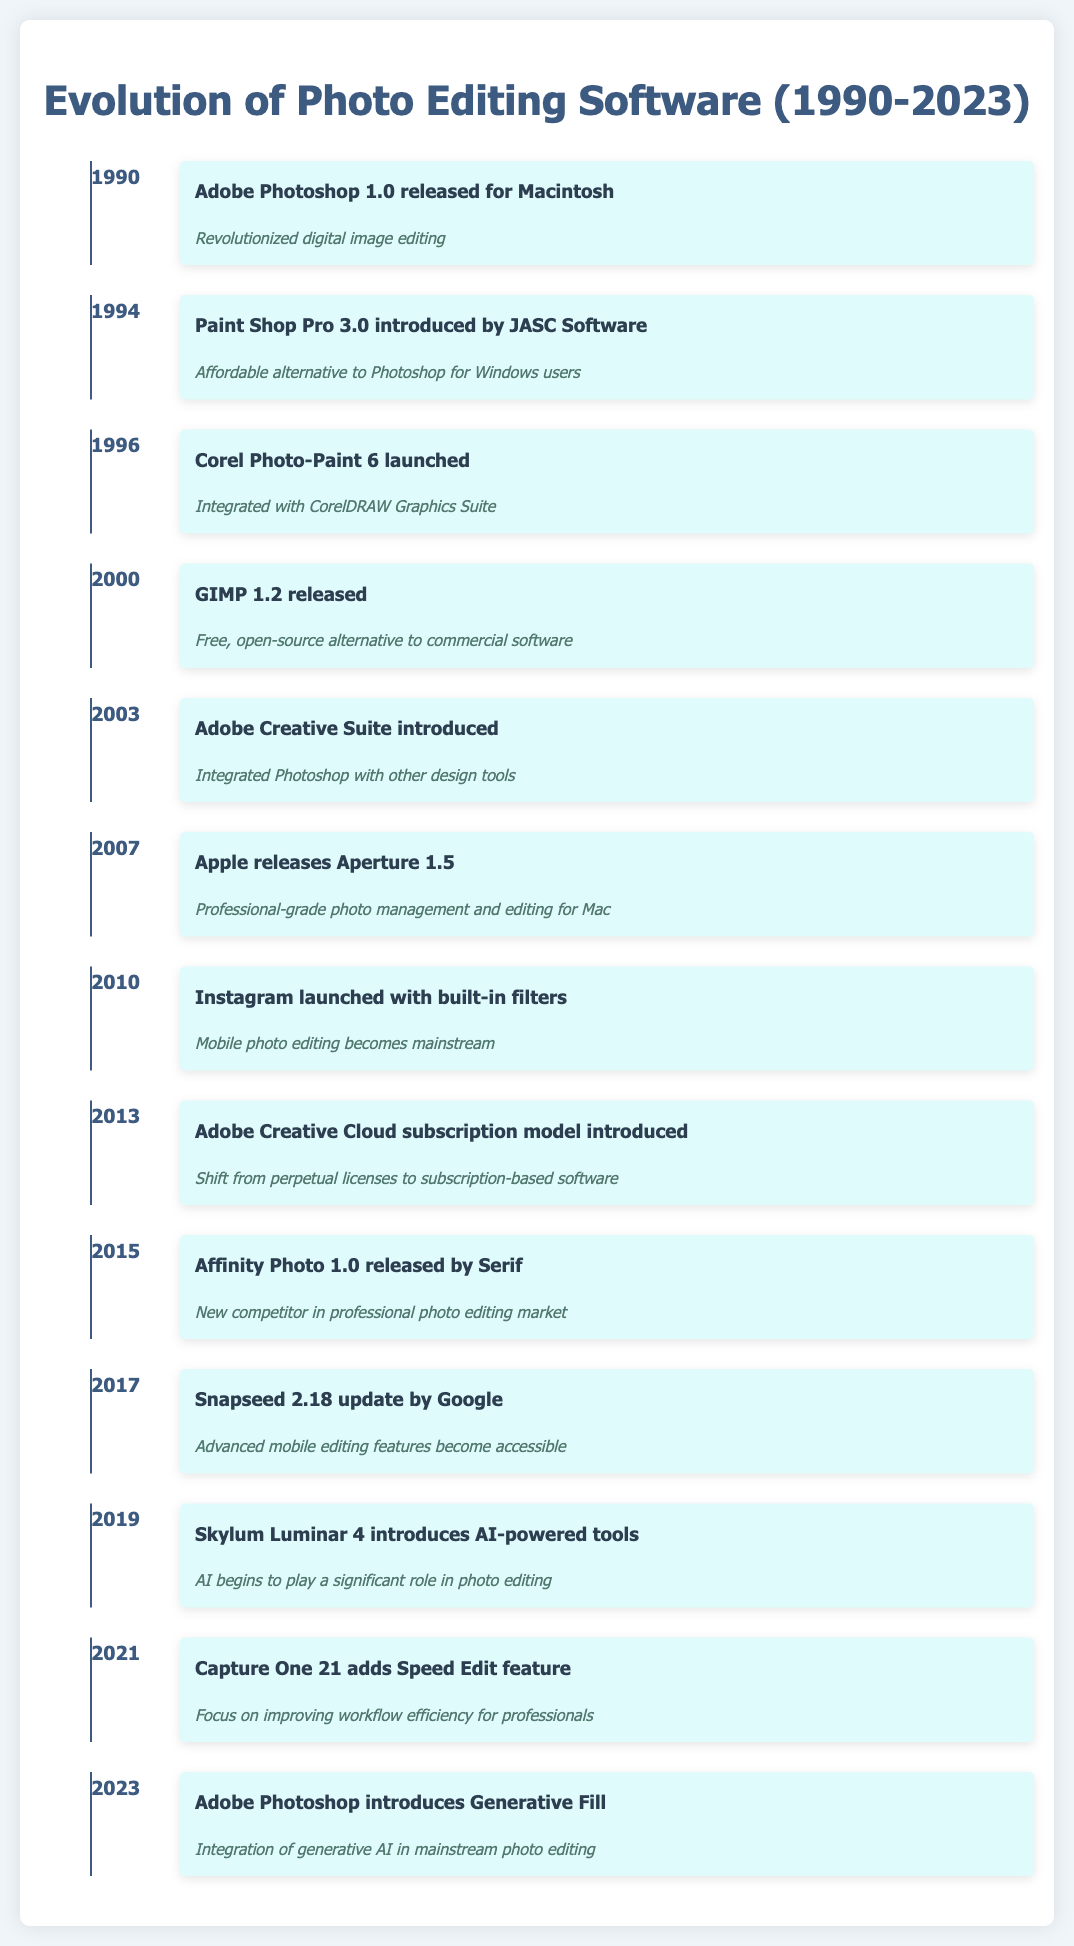What software was released in 1994? The table indicates that in 1994, "Paint Shop Pro 3.0 introduced by JASC Software" was the key event.
Answer: Paint Shop Pro 3.0 What significant change occurred in 2013 with Adobe Creative Cloud? The table states that in 2013, "Adobe Creative Cloud subscription model introduced," marking a shift from perpetual licenses to subscription-based models.
Answer: Shift to subscription model Which software was the first open-source alternative listed, and when was it released? The table indicates that "GIMP 1.2 released" in 2000 was the first open-source alternative mentioned.
Answer: GIMP 1.2 in 2000 Which three events mention advances related to mobile photo editing? The table highlights three relevant events: "Instagram launched with built-in filters" in 2010, "Snapseed 2.18 update by Google" in 2017, and "AI begins to play a significant role in photo editing" with "Skylum Luminar 4" in 2019.
Answer: Instagram 2010, Snapseed 2017, Luminar 2019 In what year was generative AI integrated into Adobe Photoshop? The table indicates that "Adobe Photoshop introduces Generative Fill" in 2023, marking the integration of generative AI.
Answer: 2023 How many years after the release of Adobe Photoshop 1.0 was the introduction of AI tools in Skylum Luminar 4? Adobe Photoshop 1.0 was released in 1990 and Skylum Luminar 4 in 2019. The difference is 2019 - 1990 = 29 years.
Answer: 29 years Was there an event in 2007 related to photo management software? The table shows "Apple releases Aperture 1.5" in 2007, confirming that there was indeed an event related to photo management software that year.
Answer: Yes Which software launched as a significant competitor in 2015? According to the table, "Affinity Photo 1.0 released by Serif" in 2015 is noted as a new competitor in the professional photo editing market.
Answer: Affinity Photo 1.0 What is the pattern of advancement in photo editing tools over the years? The table represents a clear evolution, showing the introduction of software that emphasizes affordability, accessibility, mobile capabilities, and integration of AI, underscoring a trend towards user-friendly and advanced editing options.
Answer: Trend towards ease and AI integration 